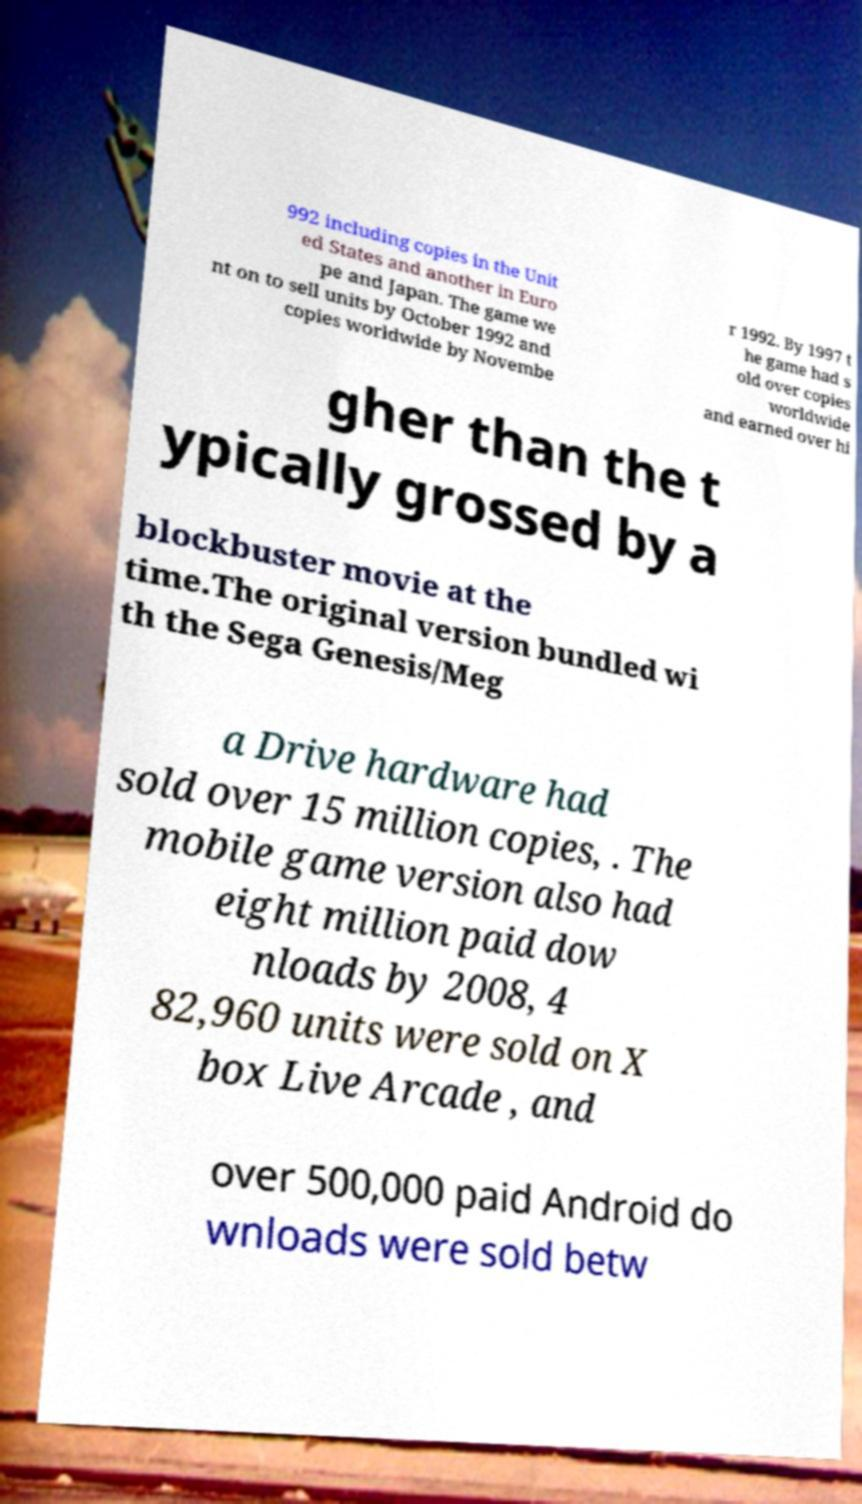Can you read and provide the text displayed in the image?This photo seems to have some interesting text. Can you extract and type it out for me? 992 including copies in the Unit ed States and another in Euro pe and Japan. The game we nt on to sell units by October 1992 and copies worldwide by Novembe r 1992. By 1997 t he game had s old over copies worldwide and earned over hi gher than the t ypically grossed by a blockbuster movie at the time.The original version bundled wi th the Sega Genesis/Meg a Drive hardware had sold over 15 million copies, . The mobile game version also had eight million paid dow nloads by 2008, 4 82,960 units were sold on X box Live Arcade , and over 500,000 paid Android do wnloads were sold betw 